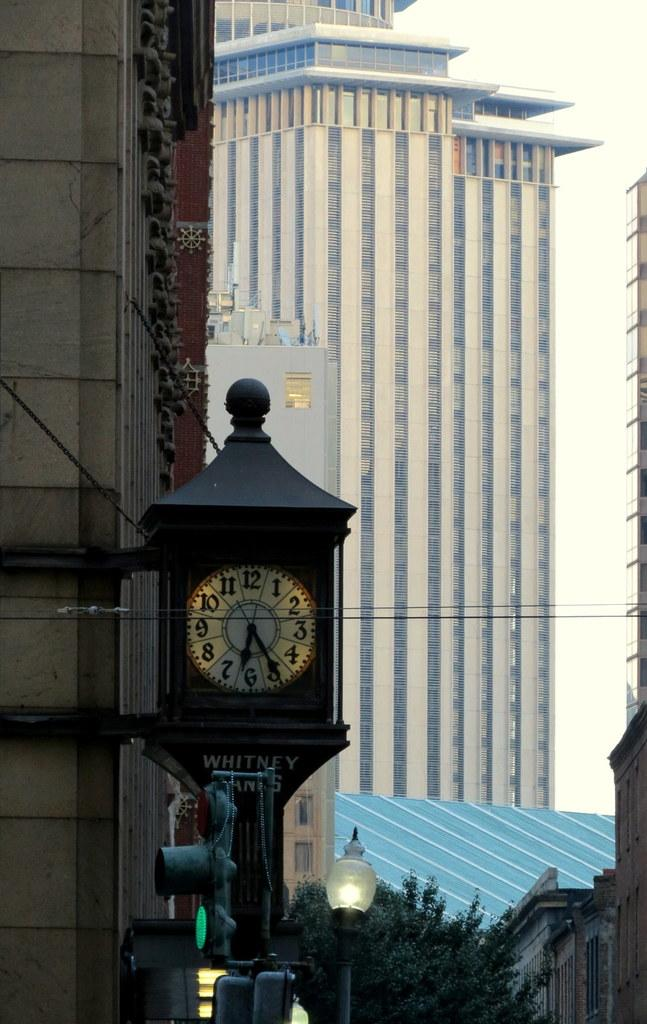<image>
Write a terse but informative summary of the picture. A clock stands on a street with the word Whitney below it. 